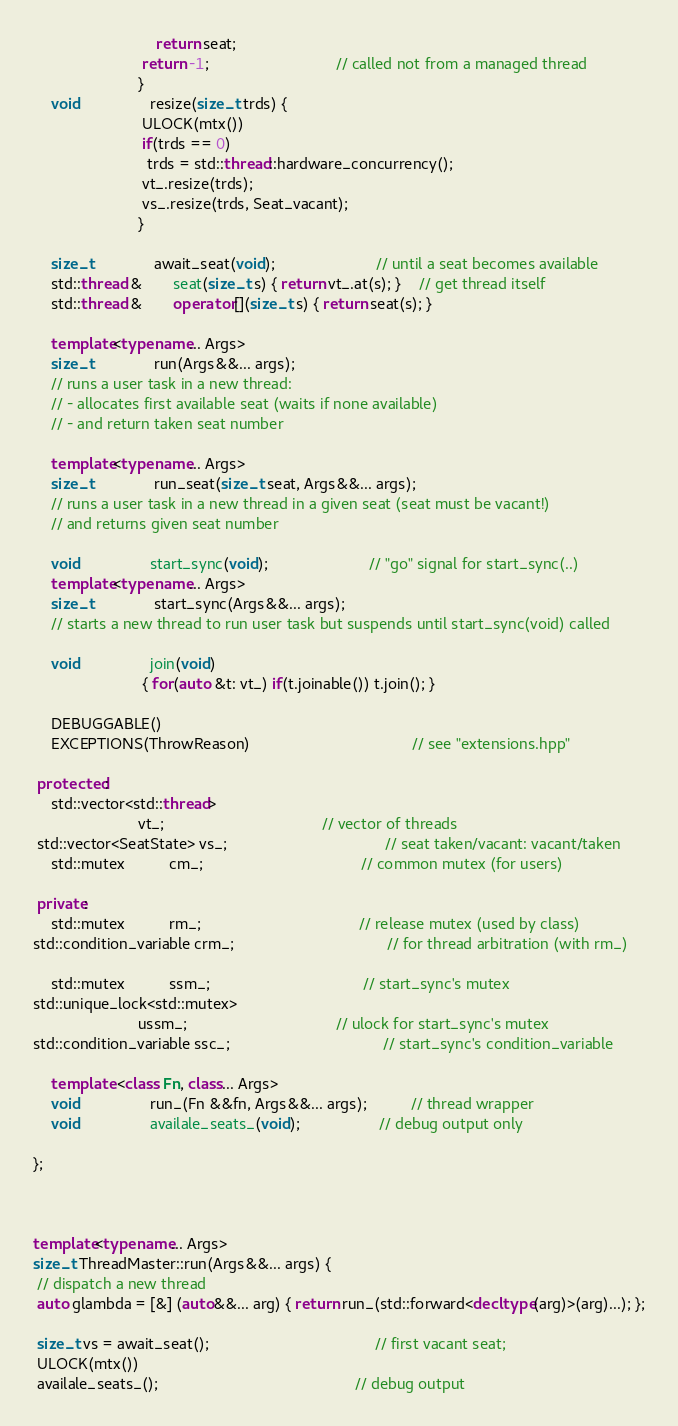Convert code to text. <code><loc_0><loc_0><loc_500><loc_500><_C++_>                            return seat;
                         return -1;                             // called not from a managed thread
                        }
    void                resize(size_t trds) {
                         ULOCK(mtx())
                         if(trds == 0)
                          trds = std::thread::hardware_concurrency();
                         vt_.resize(trds);
                         vs_.resize(trds, Seat_vacant);
                        }

    size_t              await_seat(void);                       // until a seat becomes available
    std::thread &       seat(size_t s) { return vt_.at(s); }    // get thread itself
    std::thread &       operator[](size_t s) { return seat(s); }

    template<typename... Args>
    size_t              run(Args&&... args);
    // runs a user task in a new thread:
    // - allocates first available seat (waits if none available)
    // - and return taken seat number

    template<typename... Args>
    size_t              run_seat(size_t seat, Args&&... args);
    // runs a user task in a new thread in a given seat (seat must be vacant!)
    // and returns given seat number

    void                start_sync(void);                       // "go" signal for start_sync(..)
    template<typename... Args>
    size_t              start_sync(Args&&... args);
    // starts a new thread to run user task but suspends until start_sync(void) called

    void                join(void)
                         { for(auto &t: vt_) if(t.joinable()) t.join(); }

    DEBUGGABLE()
    EXCEPTIONS(ThrowReason)                                     // see "extensions.hpp"

 protected:
    std::vector<std::thread>
                        vt_;                                    // vector of threads
 std::vector<SeatState> vs_;                                    // seat taken/vacant: vacant/taken
    std::mutex          cm_;                                    // common mutex (for users)

 private:
    std::mutex          rm_;                                    // release mutex (used by class)
std::condition_variable crm_;                                   // for thread arbitration (with rm_)

    std::mutex          ssm_;                                   // start_sync's mutex
std::unique_lock<std::mutex>
                        ussm_;                                  // ulock for start_sync's mutex
std::condition_variable ssc_;                                   // start_sync's condition_variable

    template <class Fn, class... Args>
    void                run_(Fn &&fn, Args&&... args);          // thread wrapper
    void                availale_seats_(void);                  // debug output only

};



template<typename... Args>
size_t ThreadMaster::run(Args&&... args) {
 // dispatch a new thread
 auto glambda = [&] (auto&&... arg) { return run_(std::forward<decltype(arg)>(arg)...); };

 size_t vs = await_seat();                                      // first vacant seat;
 ULOCK(mtx())
 availale_seats_();                                             // debug output</code> 